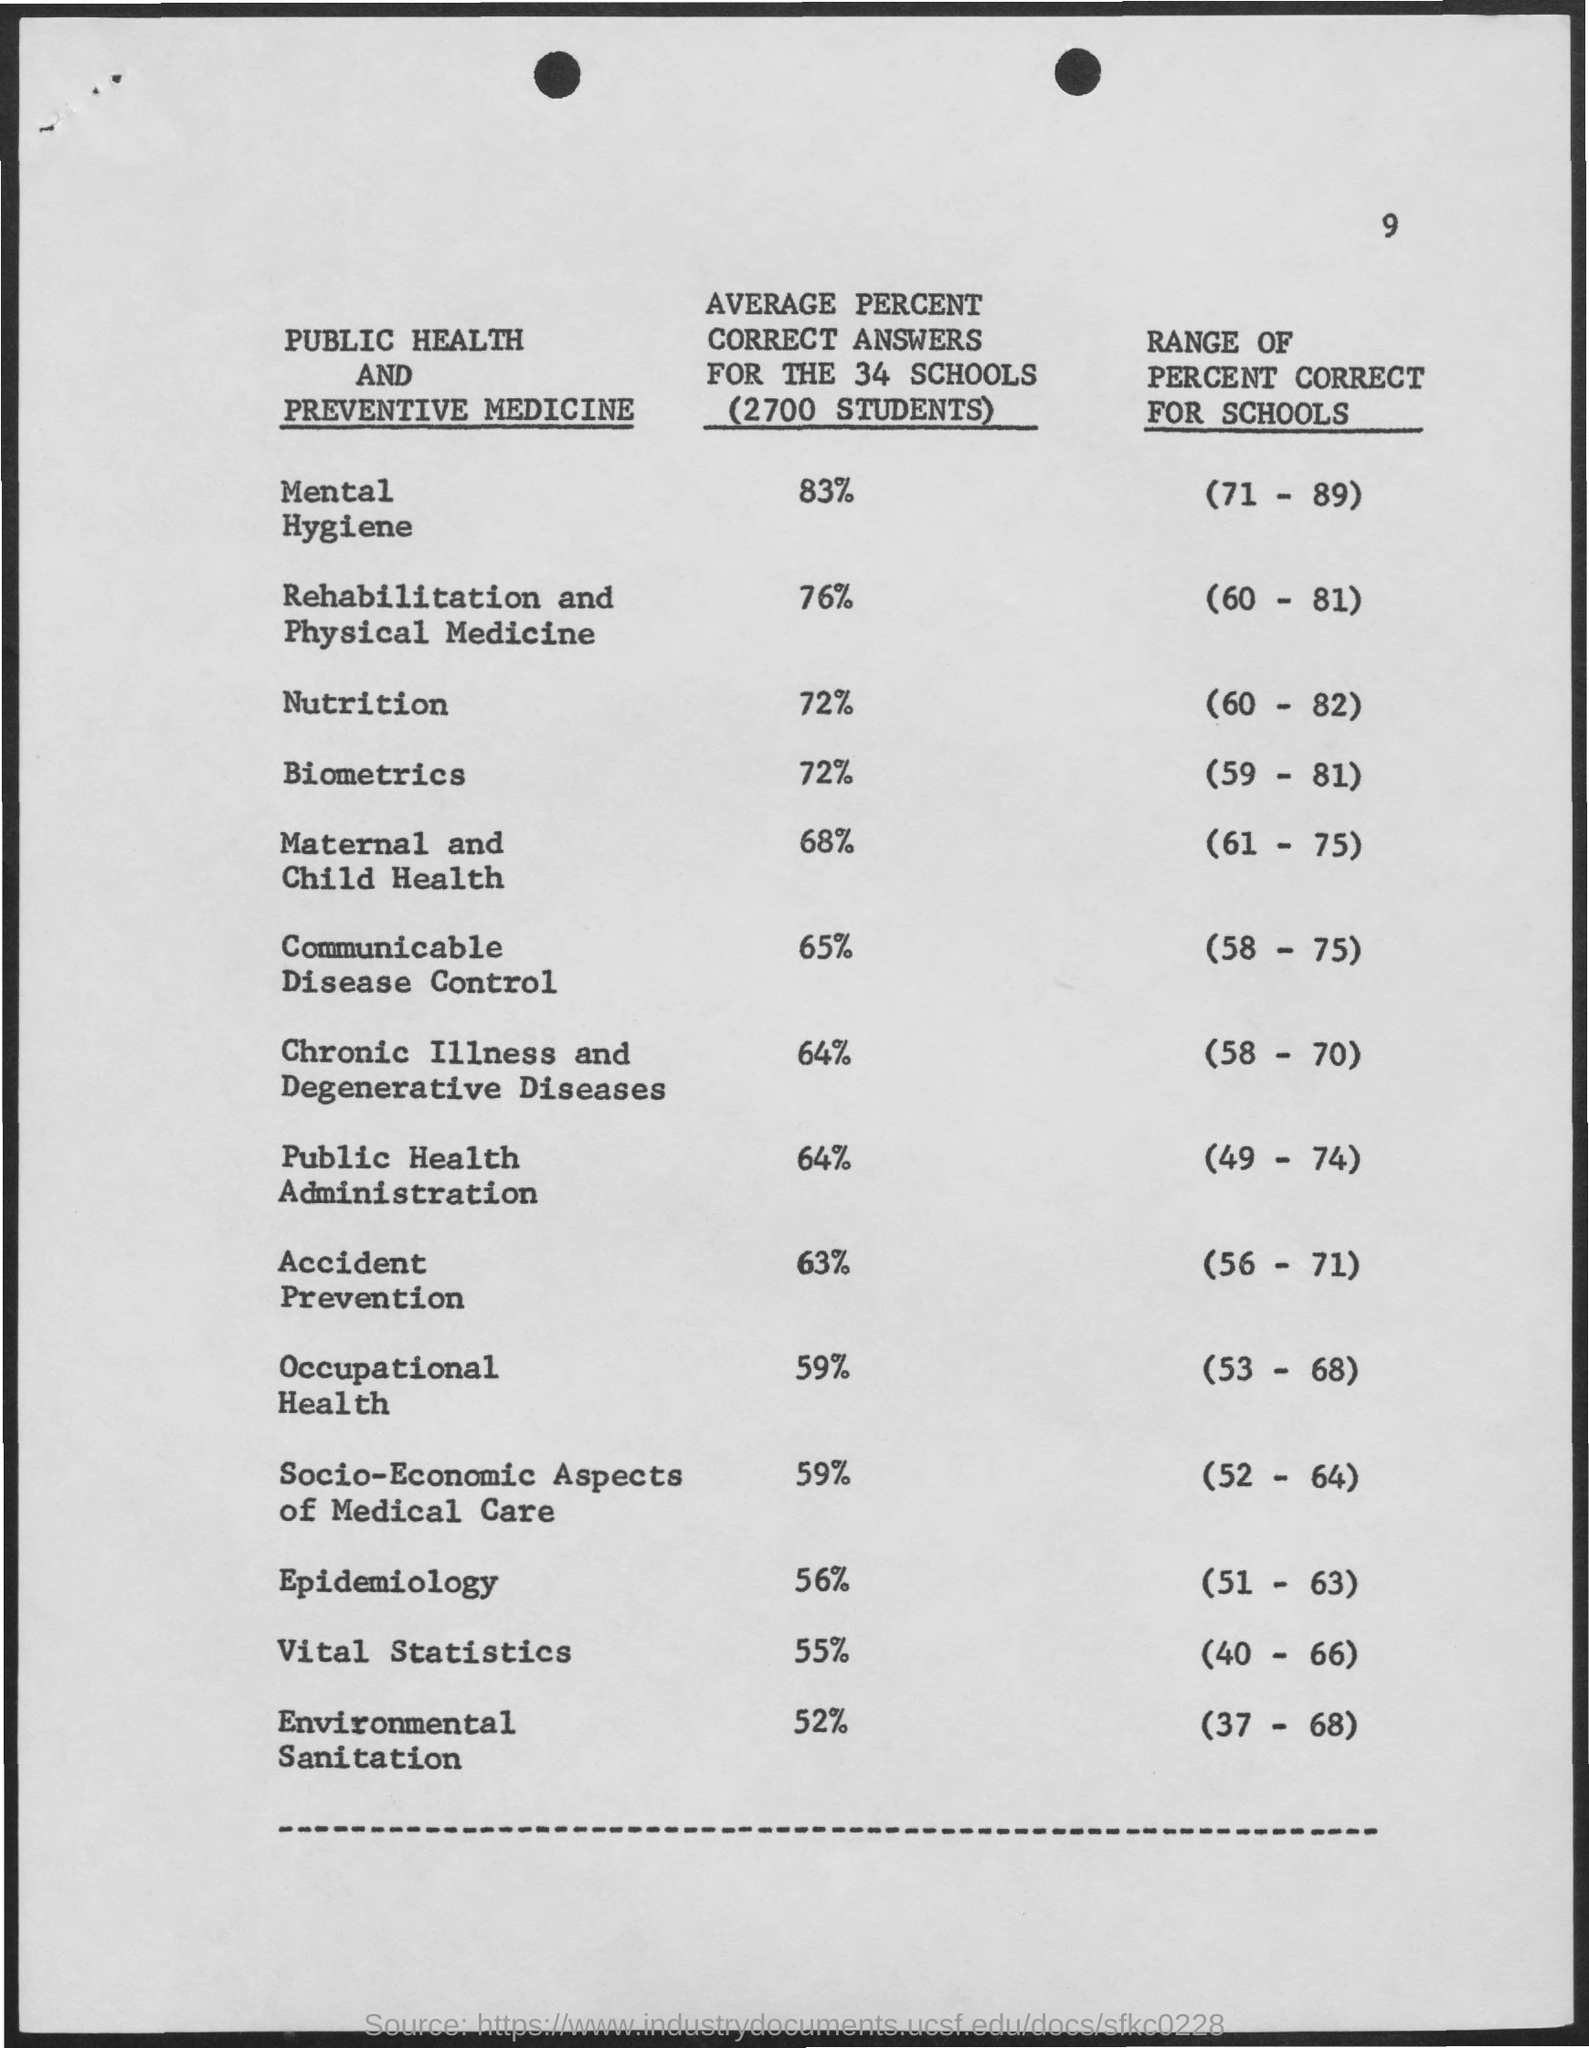What is the Page Number?
Your response must be concise. 9. 